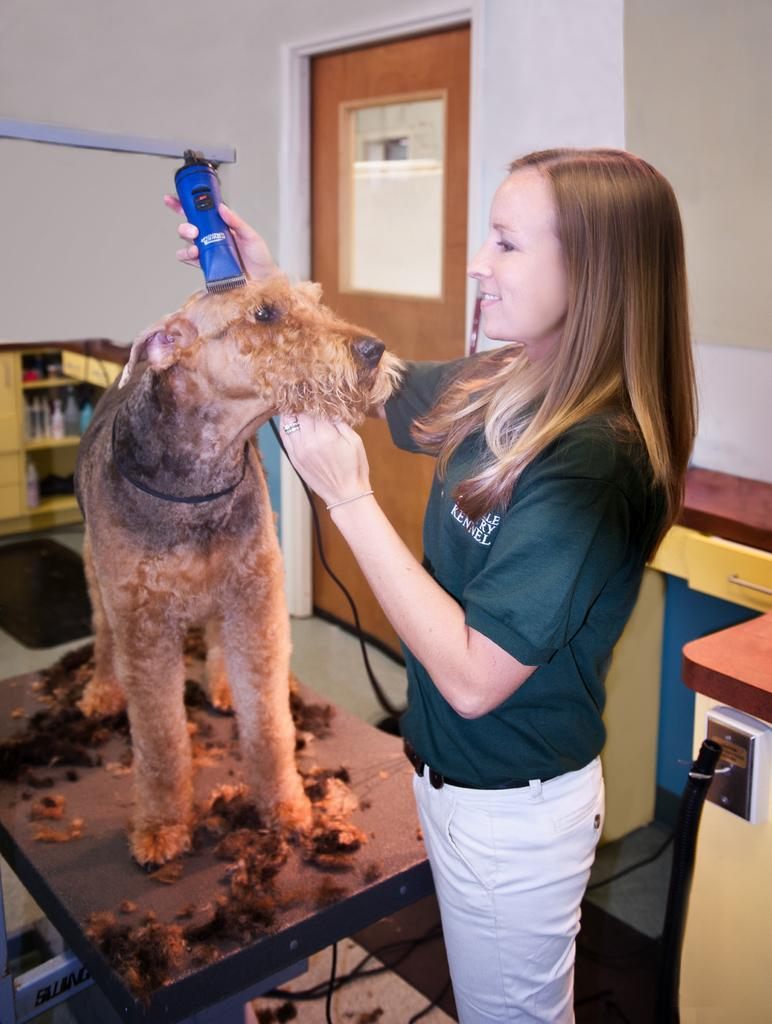Who is present in the image? There is a woman in the image. What is the woman doing in the image? The woman is standing on the floor and holding a dog. Where is the dog located in the image? The dog is on a table. What can be seen in the background of the image? There is a door and a wall in the background of the image. What type of square shirt is the woman wearing in the image? There is no shirt mentioned in the facts provided, and the image does not show the woman wearing a shirt. 